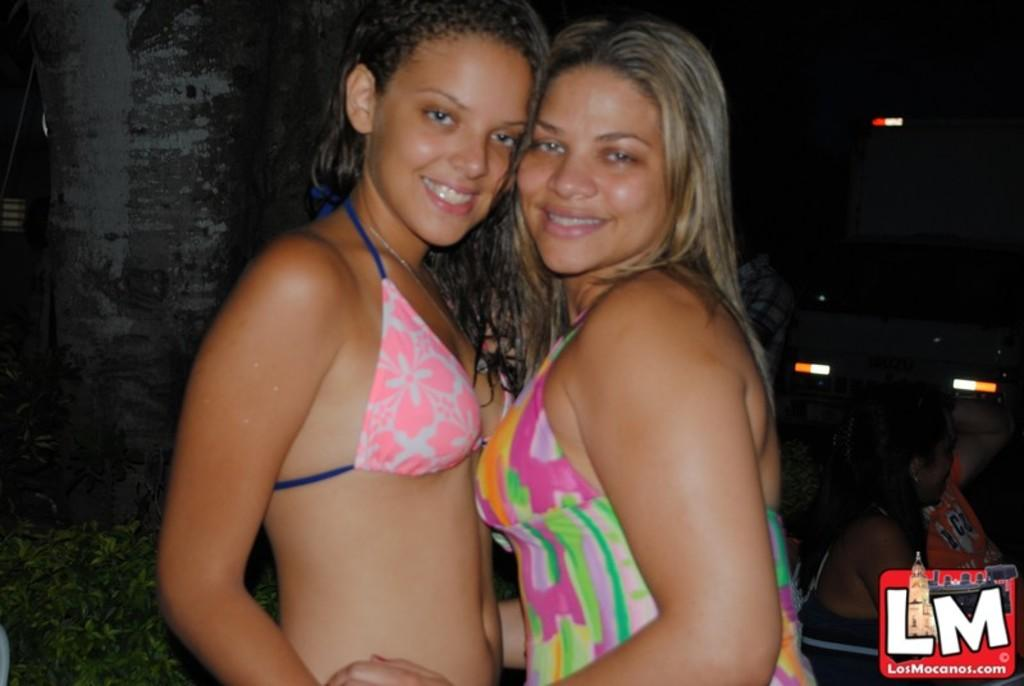What are the two persons in the image doing? The two persons in the image are standing and smiling. What can be seen in the background of the image? There are people sitting in the background of the image. What is visible in the image that might provide illumination? There are lights visible in the image. Is there any indication that the image has been reproduced or shared? Yes, there is a watermark on the image. What type of knowledge is being shared among the people in the image? There is no indication of any knowledge being shared in the image; it primarily shows people standing and smiling. 